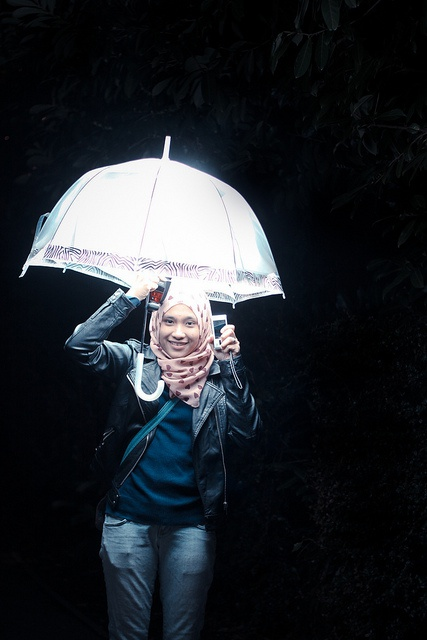Describe the objects in this image and their specific colors. I can see people in black, darkblue, white, and blue tones, umbrella in black, white, lightblue, and darkgray tones, and cell phone in black, white, gray, blue, and navy tones in this image. 